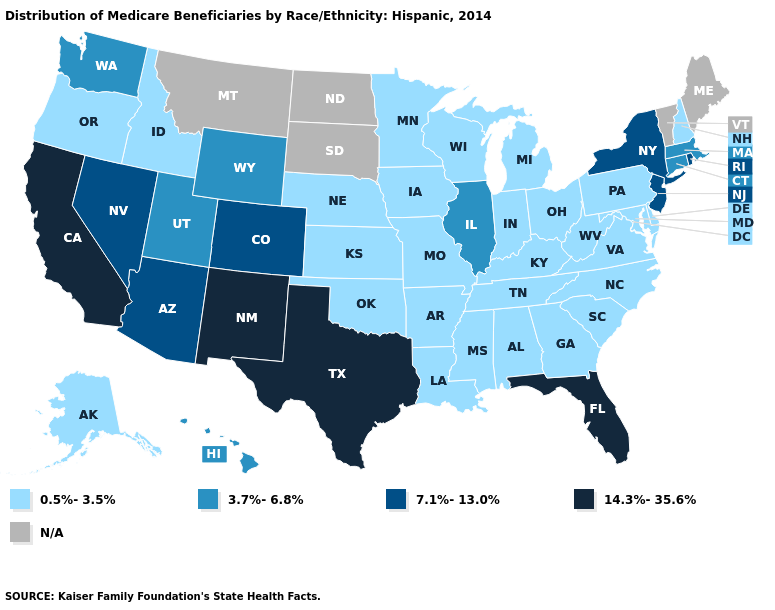What is the value of New York?
Write a very short answer. 7.1%-13.0%. Among the states that border Ohio , which have the highest value?
Be succinct. Indiana, Kentucky, Michigan, Pennsylvania, West Virginia. What is the value of Maine?
Write a very short answer. N/A. Which states have the lowest value in the USA?
Quick response, please. Alabama, Alaska, Arkansas, Delaware, Georgia, Idaho, Indiana, Iowa, Kansas, Kentucky, Louisiana, Maryland, Michigan, Minnesota, Mississippi, Missouri, Nebraska, New Hampshire, North Carolina, Ohio, Oklahoma, Oregon, Pennsylvania, South Carolina, Tennessee, Virginia, West Virginia, Wisconsin. Which states hav the highest value in the South?
Concise answer only. Florida, Texas. Does Missouri have the lowest value in the USA?
Answer briefly. Yes. Does Illinois have the highest value in the MidWest?
Keep it brief. Yes. Which states have the lowest value in the USA?
Be succinct. Alabama, Alaska, Arkansas, Delaware, Georgia, Idaho, Indiana, Iowa, Kansas, Kentucky, Louisiana, Maryland, Michigan, Minnesota, Mississippi, Missouri, Nebraska, New Hampshire, North Carolina, Ohio, Oklahoma, Oregon, Pennsylvania, South Carolina, Tennessee, Virginia, West Virginia, Wisconsin. Name the states that have a value in the range N/A?
Short answer required. Maine, Montana, North Dakota, South Dakota, Vermont. Which states hav the highest value in the MidWest?
Short answer required. Illinois. What is the value of Florida?
Be succinct. 14.3%-35.6%. Name the states that have a value in the range 3.7%-6.8%?
Answer briefly. Connecticut, Hawaii, Illinois, Massachusetts, Utah, Washington, Wyoming. 